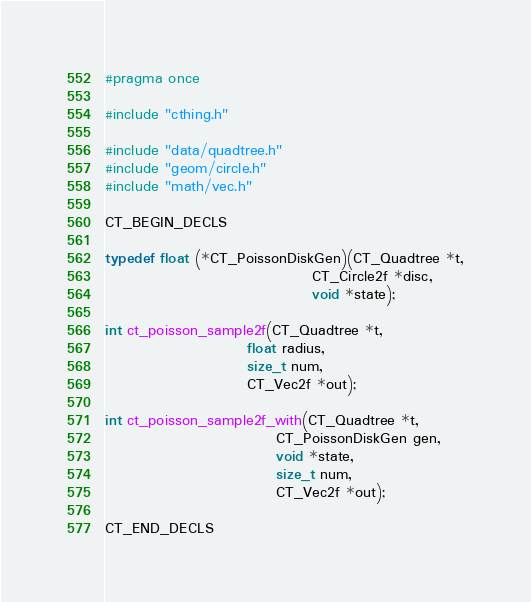<code> <loc_0><loc_0><loc_500><loc_500><_C_>#pragma once

#include "cthing.h"

#include "data/quadtree.h"
#include "geom/circle.h"
#include "math/vec.h"

CT_BEGIN_DECLS

typedef float (*CT_PoissonDiskGen)(CT_Quadtree *t,
                                   CT_Circle2f *disc,
                                   void *state);

int ct_poisson_sample2f(CT_Quadtree *t,
                        float radius,
                        size_t num,
                        CT_Vec2f *out);

int ct_poisson_sample2f_with(CT_Quadtree *t,
                             CT_PoissonDiskGen gen,
                             void *state,
                             size_t num,
                             CT_Vec2f *out);

CT_END_DECLS
</code> 